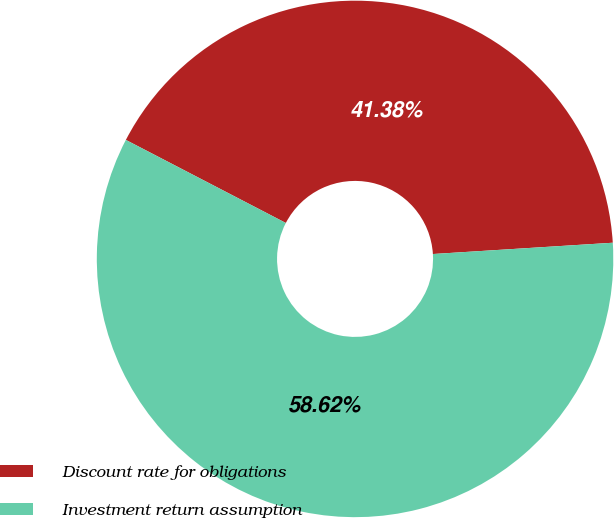Convert chart. <chart><loc_0><loc_0><loc_500><loc_500><pie_chart><fcel>Discount rate for obligations<fcel>Investment return assumption<nl><fcel>41.38%<fcel>58.62%<nl></chart> 